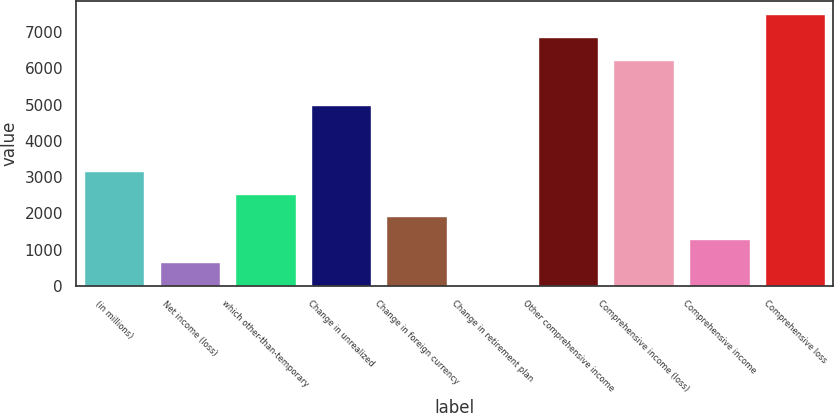Convert chart. <chart><loc_0><loc_0><loc_500><loc_500><bar_chart><fcel>(in millions)<fcel>Net income (loss)<fcel>which other-than-temporary<fcel>Change in unrealized<fcel>Change in foreign currency<fcel>Change in retirement plan<fcel>Other comprehensive income<fcel>Comprehensive income (loss)<fcel>Comprehensive income<fcel>Comprehensive loss<nl><fcel>3168<fcel>656<fcel>2540<fcel>4975<fcel>1912<fcel>28<fcel>6860<fcel>6232<fcel>1284<fcel>7488<nl></chart> 